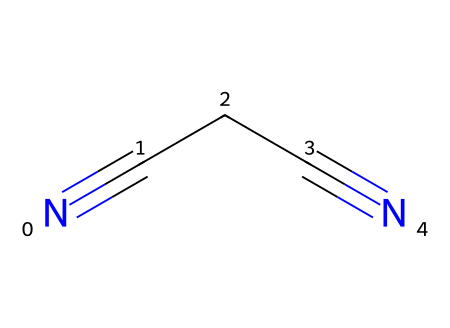How many carbon atoms are present in succinonitrile? The SMILES representation shows "N#CCC#N," indicating that there are three carbon atoms in the chain, as the "C" symbols represent carbon atoms.
Answer: 3 What is the formal name of the chemical represented by the SMILES? The SMILES "N#CCC#N" corresponds to succinonitrile, also known as butanedinitrile, because it contains a two-carbon chain with two terminal nitrile groups.
Answer: succinonitrile How many nitrogen atoms are present in this chemical structure? In the SMILES representation, "N#CCC#N" includes two "N" symbols, indicating there are two nitrogen atoms positioned at the ends of the carbon chain.
Answer: 2 What type of bonds connect the carbon and nitrogen atoms in succinonitrile? The structure shows that carbon atoms are connected to nitrogen atoms by triple bonds, represented by the "#" symbol in the SMILES notation.
Answer: triple bonds Why is succinonitrile used in battery electrolyte solutions? Succinonitrile's structure allows it to function as an excellent solvent due to its low viscosity and high dielectric constant, which facilitates ion movement in electrolyte solutions.
Answer: excellent solvent What is the functional group characteristic of nitriles present in this chemical? The presence of the "C#N" portion in the SMILES indicates the presence of the nitrile functional group, characterized by the carbon atom triple-bonded to the nitrogen atom.
Answer: nitrile group What type of chemical compound is succinonitrile? Given that succinonitrile features a carbon backbone with functional groups that include nitriles, it is classified as a nitrile compound.
Answer: nitrile 